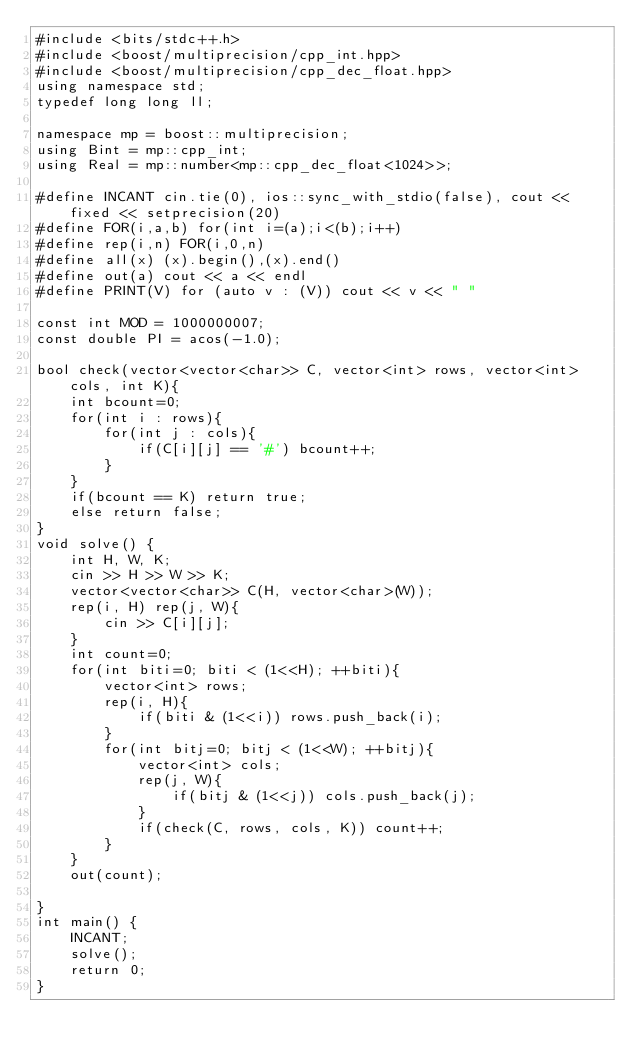<code> <loc_0><loc_0><loc_500><loc_500><_C++_>#include <bits/stdc++.h>
#include <boost/multiprecision/cpp_int.hpp>
#include <boost/multiprecision/cpp_dec_float.hpp>
using namespace std;
typedef long long ll;

namespace mp = boost::multiprecision;
using Bint = mp::cpp_int;
using Real = mp::number<mp::cpp_dec_float<1024>>;

#define INCANT cin.tie(0), ios::sync_with_stdio(false), cout << fixed << setprecision(20)
#define FOR(i,a,b) for(int i=(a);i<(b);i++)
#define rep(i,n) FOR(i,0,n)
#define all(x) (x).begin(),(x).end()
#define out(a) cout << a << endl
#define PRINT(V) for (auto v : (V)) cout << v << " "

const int MOD = 1000000007;
const double PI = acos(-1.0);

bool check(vector<vector<char>> C, vector<int> rows, vector<int> cols, int K){
    int bcount=0;
    for(int i : rows){
        for(int j : cols){
            if(C[i][j] == '#') bcount++;
        }
    }
    if(bcount == K) return true;
    else return false;
}
void solve() {
    int H, W, K;
    cin >> H >> W >> K;
    vector<vector<char>> C(H, vector<char>(W));
    rep(i, H) rep(j, W){
        cin >> C[i][j];
    }
    int count=0;
    for(int biti=0; biti < (1<<H); ++biti){
        vector<int> rows;
        rep(i, H){
            if(biti & (1<<i)) rows.push_back(i);
        }
        for(int bitj=0; bitj < (1<<W); ++bitj){
            vector<int> cols;
            rep(j, W){
                if(bitj & (1<<j)) cols.push_back(j);
            }
            if(check(C, rows, cols, K)) count++;
        }
    }
    out(count);

}
int main() {
    INCANT;
    solve();
    return 0;
}


</code> 